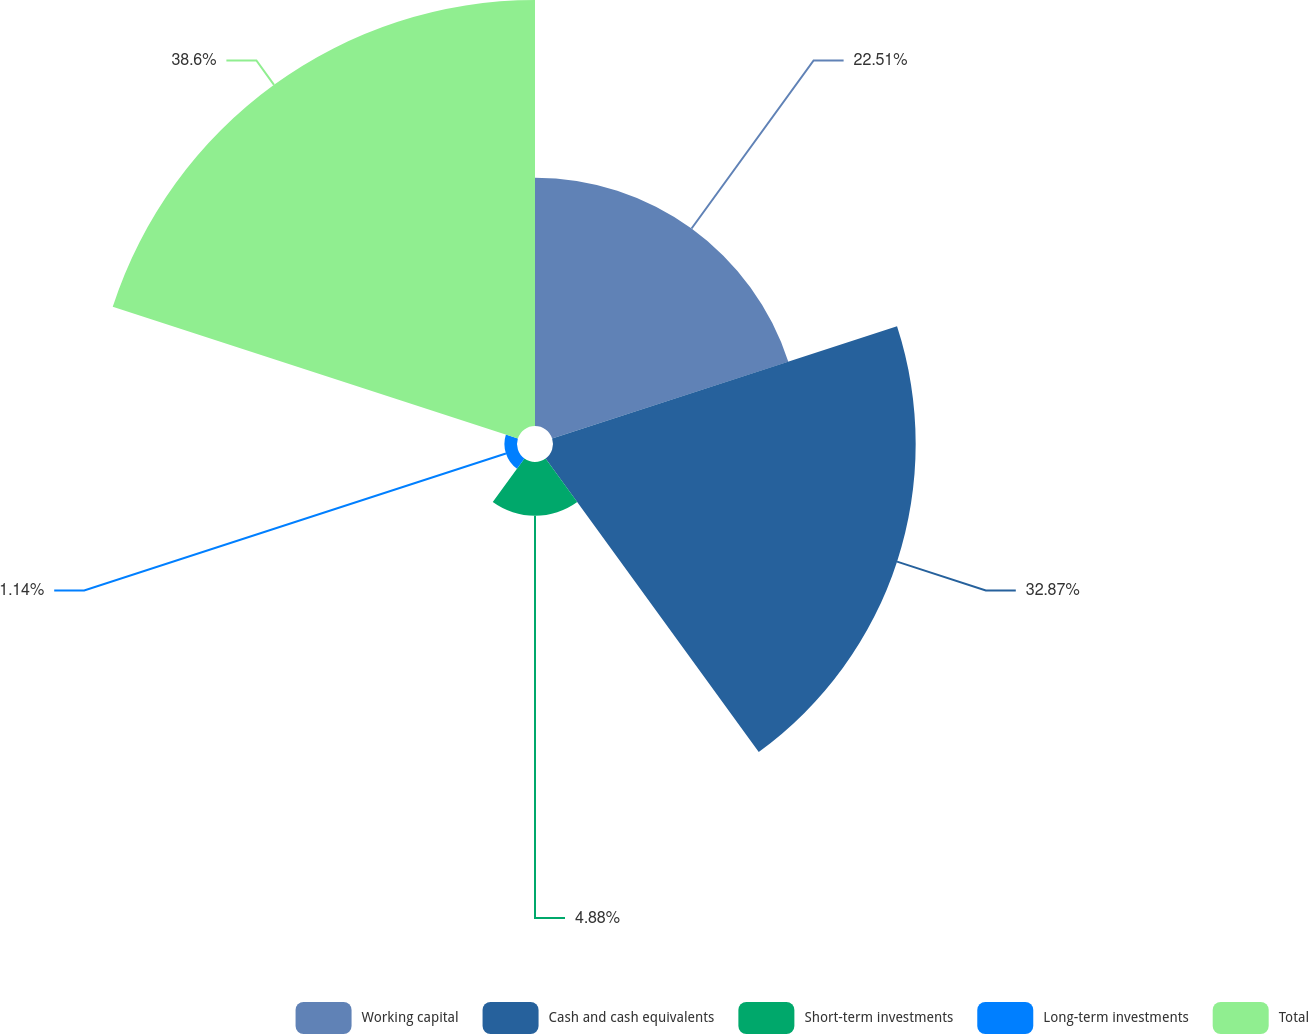Convert chart to OTSL. <chart><loc_0><loc_0><loc_500><loc_500><pie_chart><fcel>Working capital<fcel>Cash and cash equivalents<fcel>Short-term investments<fcel>Long-term investments<fcel>Total<nl><fcel>22.51%<fcel>32.87%<fcel>4.88%<fcel>1.14%<fcel>38.61%<nl></chart> 